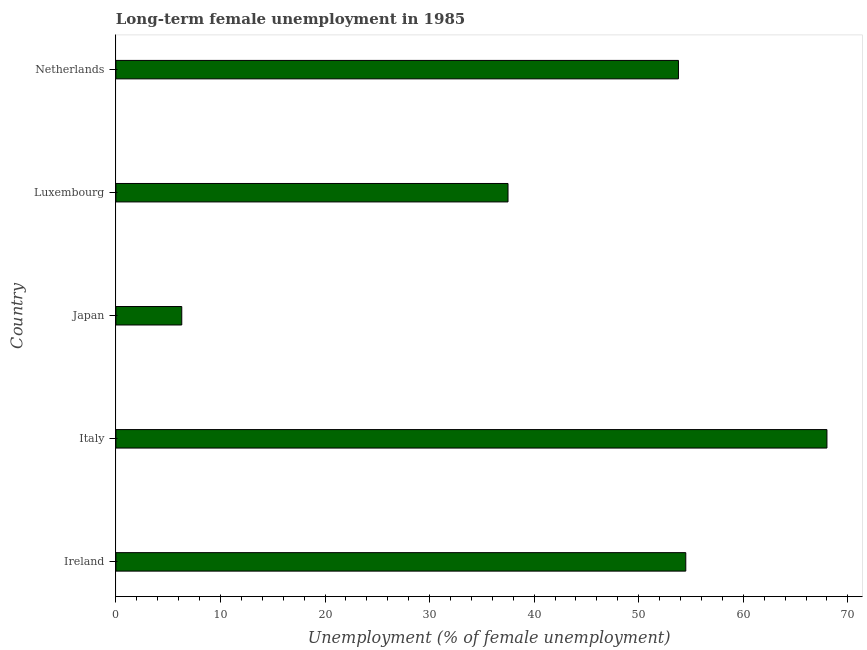Does the graph contain grids?
Keep it short and to the point. No. What is the title of the graph?
Keep it short and to the point. Long-term female unemployment in 1985. What is the label or title of the X-axis?
Your answer should be compact. Unemployment (% of female unemployment). What is the label or title of the Y-axis?
Your answer should be compact. Country. Across all countries, what is the minimum long-term female unemployment?
Offer a terse response. 6.3. In which country was the long-term female unemployment maximum?
Offer a terse response. Italy. What is the sum of the long-term female unemployment?
Provide a succinct answer. 220.1. What is the difference between the long-term female unemployment in Italy and Netherlands?
Provide a short and direct response. 14.2. What is the average long-term female unemployment per country?
Make the answer very short. 44.02. What is the median long-term female unemployment?
Provide a short and direct response. 53.8. What is the ratio of the long-term female unemployment in Ireland to that in Netherlands?
Keep it short and to the point. 1.01. What is the difference between the highest and the lowest long-term female unemployment?
Your answer should be very brief. 61.7. How many countries are there in the graph?
Make the answer very short. 5. What is the difference between two consecutive major ticks on the X-axis?
Provide a short and direct response. 10. Are the values on the major ticks of X-axis written in scientific E-notation?
Provide a succinct answer. No. What is the Unemployment (% of female unemployment) in Ireland?
Offer a terse response. 54.5. What is the Unemployment (% of female unemployment) of Italy?
Make the answer very short. 68. What is the Unemployment (% of female unemployment) in Japan?
Keep it short and to the point. 6.3. What is the Unemployment (% of female unemployment) of Luxembourg?
Your answer should be compact. 37.5. What is the Unemployment (% of female unemployment) of Netherlands?
Your response must be concise. 53.8. What is the difference between the Unemployment (% of female unemployment) in Ireland and Italy?
Provide a succinct answer. -13.5. What is the difference between the Unemployment (% of female unemployment) in Ireland and Japan?
Ensure brevity in your answer.  48.2. What is the difference between the Unemployment (% of female unemployment) in Italy and Japan?
Your answer should be very brief. 61.7. What is the difference between the Unemployment (% of female unemployment) in Italy and Luxembourg?
Your response must be concise. 30.5. What is the difference between the Unemployment (% of female unemployment) in Japan and Luxembourg?
Provide a short and direct response. -31.2. What is the difference between the Unemployment (% of female unemployment) in Japan and Netherlands?
Your answer should be very brief. -47.5. What is the difference between the Unemployment (% of female unemployment) in Luxembourg and Netherlands?
Your answer should be compact. -16.3. What is the ratio of the Unemployment (% of female unemployment) in Ireland to that in Italy?
Offer a terse response. 0.8. What is the ratio of the Unemployment (% of female unemployment) in Ireland to that in Japan?
Offer a terse response. 8.65. What is the ratio of the Unemployment (% of female unemployment) in Ireland to that in Luxembourg?
Keep it short and to the point. 1.45. What is the ratio of the Unemployment (% of female unemployment) in Italy to that in Japan?
Your answer should be compact. 10.79. What is the ratio of the Unemployment (% of female unemployment) in Italy to that in Luxembourg?
Give a very brief answer. 1.81. What is the ratio of the Unemployment (% of female unemployment) in Italy to that in Netherlands?
Offer a terse response. 1.26. What is the ratio of the Unemployment (% of female unemployment) in Japan to that in Luxembourg?
Your answer should be compact. 0.17. What is the ratio of the Unemployment (% of female unemployment) in Japan to that in Netherlands?
Ensure brevity in your answer.  0.12. What is the ratio of the Unemployment (% of female unemployment) in Luxembourg to that in Netherlands?
Offer a very short reply. 0.7. 